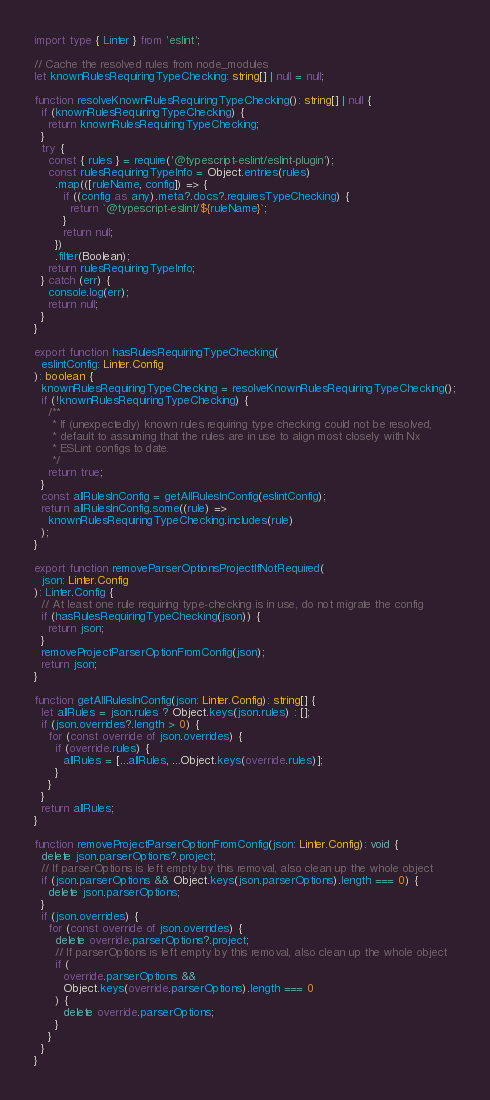<code> <loc_0><loc_0><loc_500><loc_500><_TypeScript_>import type { Linter } from 'eslint';

// Cache the resolved rules from node_modules
let knownRulesRequiringTypeChecking: string[] | null = null;

function resolveKnownRulesRequiringTypeChecking(): string[] | null {
  if (knownRulesRequiringTypeChecking) {
    return knownRulesRequiringTypeChecking;
  }
  try {
    const { rules } = require('@typescript-eslint/eslint-plugin');
    const rulesRequiringTypeInfo = Object.entries(rules)
      .map(([ruleName, config]) => {
        if ((config as any).meta?.docs?.requiresTypeChecking) {
          return `@typescript-eslint/${ruleName}`;
        }
        return null;
      })
      .filter(Boolean);
    return rulesRequiringTypeInfo;
  } catch (err) {
    console.log(err);
    return null;
  }
}

export function hasRulesRequiringTypeChecking(
  eslintConfig: Linter.Config
): boolean {
  knownRulesRequiringTypeChecking = resolveKnownRulesRequiringTypeChecking();
  if (!knownRulesRequiringTypeChecking) {
    /**
     * If (unexpectedly) known rules requiring type checking could not be resolved,
     * default to assuming that the rules are in use to align most closely with Nx
     * ESLint configs to date.
     */
    return true;
  }
  const allRulesInConfig = getAllRulesInConfig(eslintConfig);
  return allRulesInConfig.some((rule) =>
    knownRulesRequiringTypeChecking.includes(rule)
  );
}

export function removeParserOptionsProjectIfNotRequired(
  json: Linter.Config
): Linter.Config {
  // At least one rule requiring type-checking is in use, do not migrate the config
  if (hasRulesRequiringTypeChecking(json)) {
    return json;
  }
  removeProjectParserOptionFromConfig(json);
  return json;
}

function getAllRulesInConfig(json: Linter.Config): string[] {
  let allRules = json.rules ? Object.keys(json.rules) : [];
  if (json.overrides?.length > 0) {
    for (const override of json.overrides) {
      if (override.rules) {
        allRules = [...allRules, ...Object.keys(override.rules)];
      }
    }
  }
  return allRules;
}

function removeProjectParserOptionFromConfig(json: Linter.Config): void {
  delete json.parserOptions?.project;
  // If parserOptions is left empty by this removal, also clean up the whole object
  if (json.parserOptions && Object.keys(json.parserOptions).length === 0) {
    delete json.parserOptions;
  }
  if (json.overrides) {
    for (const override of json.overrides) {
      delete override.parserOptions?.project;
      // If parserOptions is left empty by this removal, also clean up the whole object
      if (
        override.parserOptions &&
        Object.keys(override.parserOptions).length === 0
      ) {
        delete override.parserOptions;
      }
    }
  }
}
</code> 